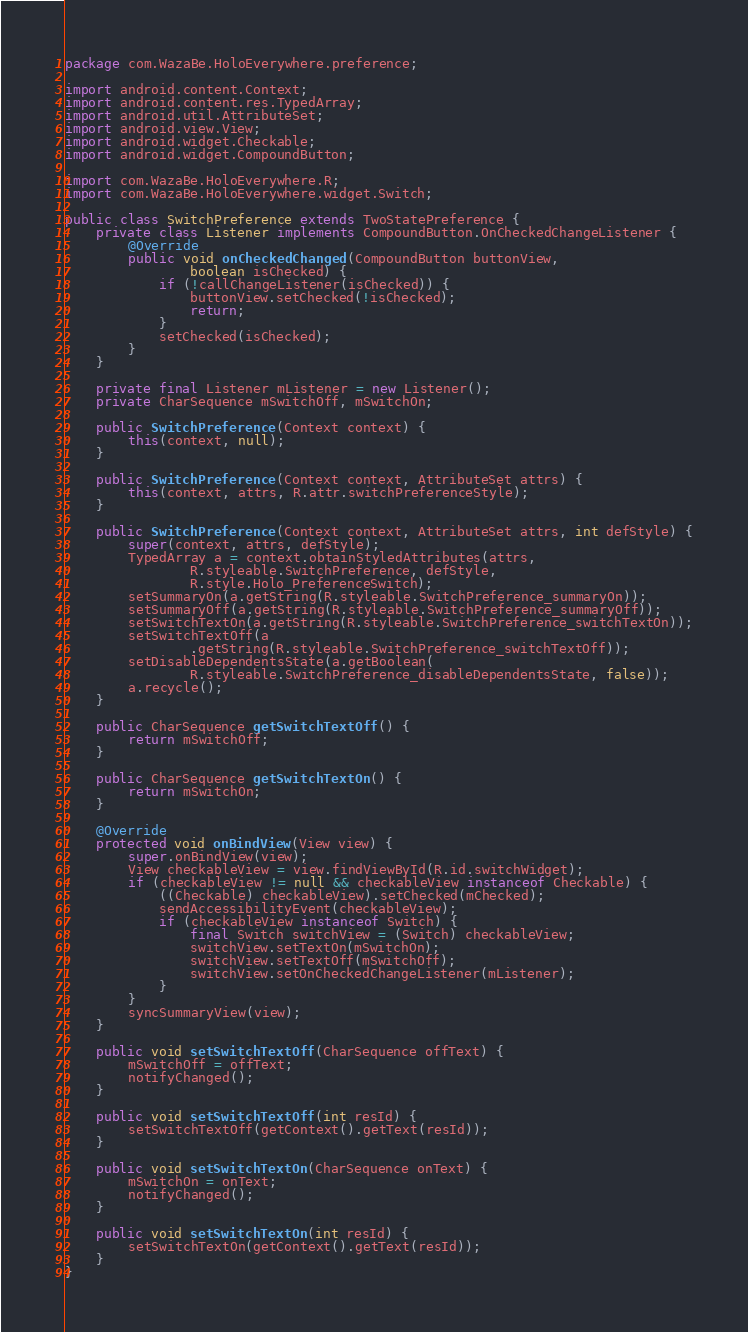<code> <loc_0><loc_0><loc_500><loc_500><_Java_>package com.WazaBe.HoloEverywhere.preference;

import android.content.Context;
import android.content.res.TypedArray;
import android.util.AttributeSet;
import android.view.View;
import android.widget.Checkable;
import android.widget.CompoundButton;

import com.WazaBe.HoloEverywhere.R;
import com.WazaBe.HoloEverywhere.widget.Switch;

public class SwitchPreference extends TwoStatePreference {
	private class Listener implements CompoundButton.OnCheckedChangeListener {
		@Override
		public void onCheckedChanged(CompoundButton buttonView,
				boolean isChecked) {
			if (!callChangeListener(isChecked)) {
				buttonView.setChecked(!isChecked);
				return;
			}
			setChecked(isChecked);
		}
	}

	private final Listener mListener = new Listener();
	private CharSequence mSwitchOff, mSwitchOn;

	public SwitchPreference(Context context) {
		this(context, null);
	}

	public SwitchPreference(Context context, AttributeSet attrs) {
		this(context, attrs, R.attr.switchPreferenceStyle);
	}

	public SwitchPreference(Context context, AttributeSet attrs, int defStyle) {
		super(context, attrs, defStyle);
		TypedArray a = context.obtainStyledAttributes(attrs,
				R.styleable.SwitchPreference, defStyle,
				R.style.Holo_PreferenceSwitch);
		setSummaryOn(a.getString(R.styleable.SwitchPreference_summaryOn));
		setSummaryOff(a.getString(R.styleable.SwitchPreference_summaryOff));
		setSwitchTextOn(a.getString(R.styleable.SwitchPreference_switchTextOn));
		setSwitchTextOff(a
				.getString(R.styleable.SwitchPreference_switchTextOff));
		setDisableDependentsState(a.getBoolean(
				R.styleable.SwitchPreference_disableDependentsState, false));
		a.recycle();
	}

	public CharSequence getSwitchTextOff() {
		return mSwitchOff;
	}

	public CharSequence getSwitchTextOn() {
		return mSwitchOn;
	}

	@Override
	protected void onBindView(View view) {
		super.onBindView(view);
		View checkableView = view.findViewById(R.id.switchWidget);
		if (checkableView != null && checkableView instanceof Checkable) {
			((Checkable) checkableView).setChecked(mChecked);
			sendAccessibilityEvent(checkableView);
			if (checkableView instanceof Switch) {
				final Switch switchView = (Switch) checkableView;
				switchView.setTextOn(mSwitchOn);
				switchView.setTextOff(mSwitchOff);
				switchView.setOnCheckedChangeListener(mListener);
			}
		}
		syncSummaryView(view);
	}

	public void setSwitchTextOff(CharSequence offText) {
		mSwitchOff = offText;
		notifyChanged();
	}

	public void setSwitchTextOff(int resId) {
		setSwitchTextOff(getContext().getText(resId));
	}

	public void setSwitchTextOn(CharSequence onText) {
		mSwitchOn = onText;
		notifyChanged();
	}

	public void setSwitchTextOn(int resId) {
		setSwitchTextOn(getContext().getText(resId));
	}
}
</code> 